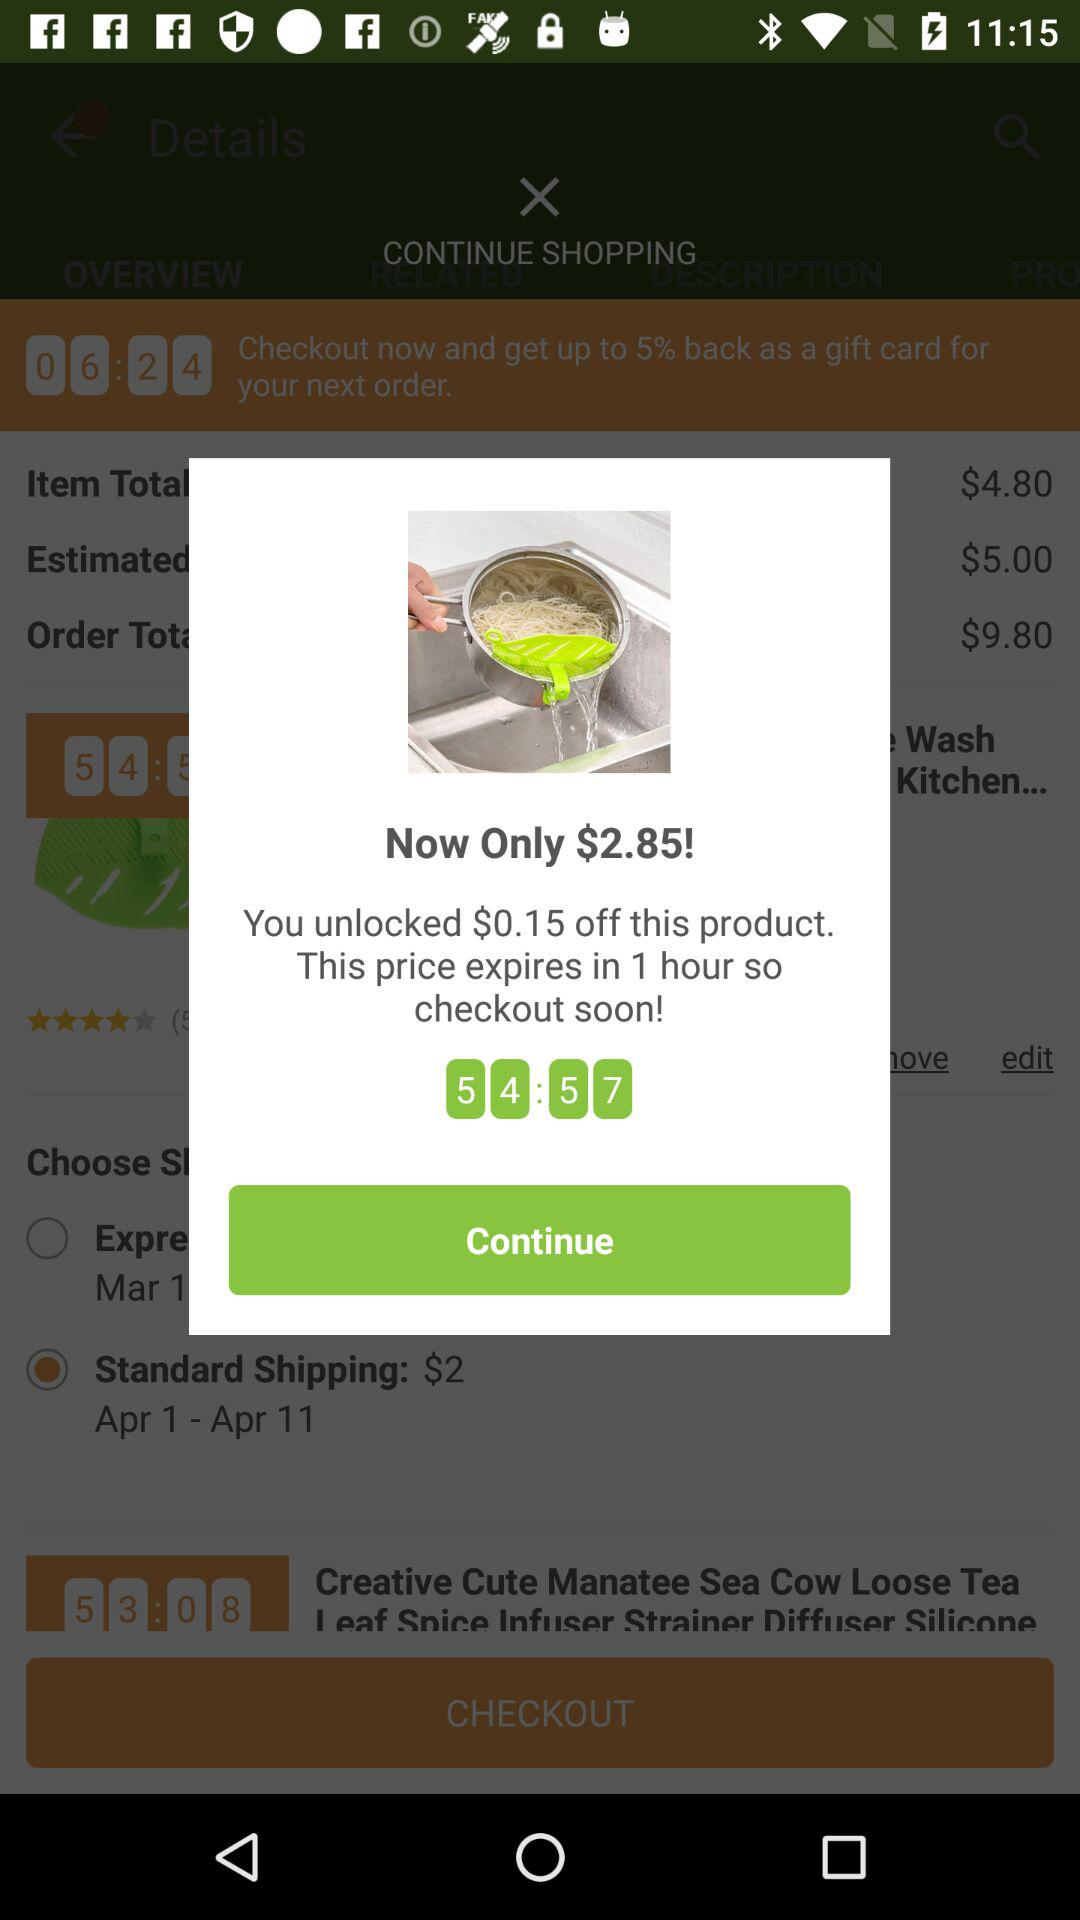What discount is unlocked on the product? The unlocked discount is $0.15. 